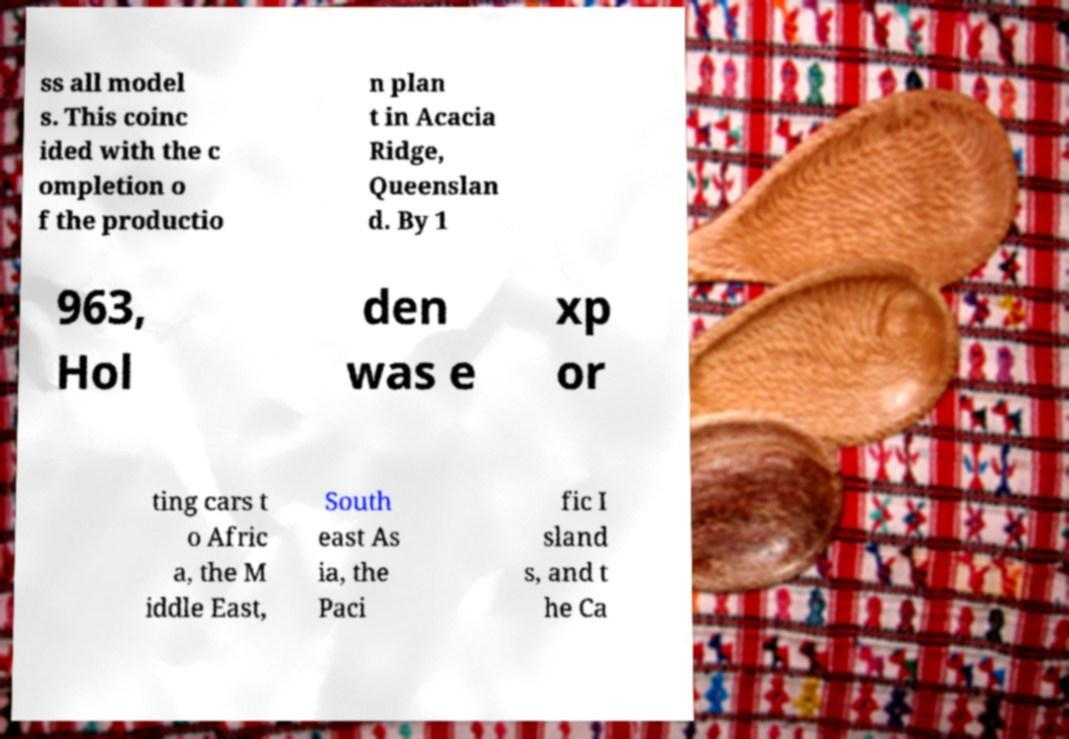There's text embedded in this image that I need extracted. Can you transcribe it verbatim? ss all model s. This coinc ided with the c ompletion o f the productio n plan t in Acacia Ridge, Queenslan d. By 1 963, Hol den was e xp or ting cars t o Afric a, the M iddle East, South east As ia, the Paci fic I sland s, and t he Ca 